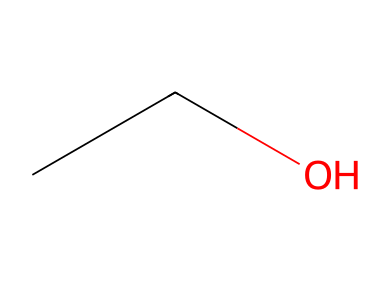What type of alcohol is represented by this structure? The presence of the hydroxyl (-OH) group attached to the carbon chain in "CCO" identifies this compound as an alcohol. Specifically, it is ethanol, which is a simple alcohol.
Answer: alcohol What is the functional group in ethanol? In the structural representation of ethanol, the -OH group attached to the carbon chain is the functional group that classifies it as an alcohol. The hydroxyl group is responsible for its properties as an alcohol.
Answer: hydroxyl How many hydrogen atoms are bonded to each carbon in this molecule? In the SMILES "CCO," the two carbons are both saturated and each carbon atom is bonded to three hydrogen atoms, while one of the carbons is also bonded to the hydroxyl group. Thus, there are three hydrogen atoms on one carbon and two on another.
Answer: 3 and 2 What type of hydrocarbon is ethanol categorized as? Ethanol, represented by "CCO," is categorized as a saturated hydrocarbon due to the single bonds between carbon atoms and the presence of the -OH group, which makes it an alcohol, a subclass of hydrocarbons.
Answer: saturated hydrocarbon 